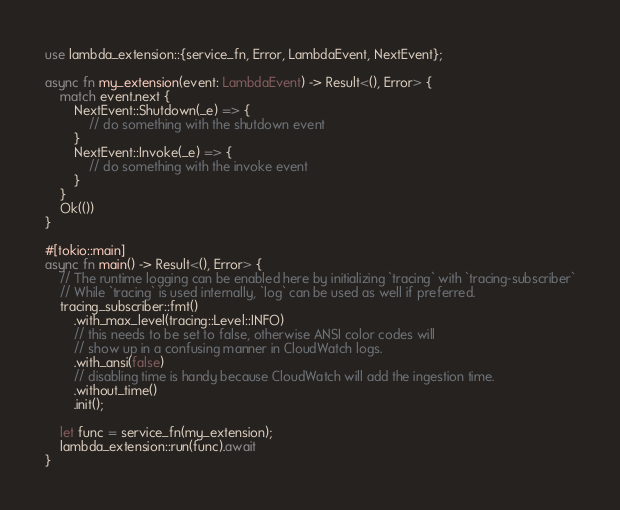<code> <loc_0><loc_0><loc_500><loc_500><_Rust_>use lambda_extension::{service_fn, Error, LambdaEvent, NextEvent};

async fn my_extension(event: LambdaEvent) -> Result<(), Error> {
    match event.next {
        NextEvent::Shutdown(_e) => {
            // do something with the shutdown event
        }
        NextEvent::Invoke(_e) => {
            // do something with the invoke event
        }
    }
    Ok(())
}

#[tokio::main]
async fn main() -> Result<(), Error> {
    // The runtime logging can be enabled here by initializing `tracing` with `tracing-subscriber`
    // While `tracing` is used internally, `log` can be used as well if preferred.
    tracing_subscriber::fmt()
        .with_max_level(tracing::Level::INFO)
        // this needs to be set to false, otherwise ANSI color codes will
        // show up in a confusing manner in CloudWatch logs.
        .with_ansi(false)
        // disabling time is handy because CloudWatch will add the ingestion time.
        .without_time()
        .init();

    let func = service_fn(my_extension);
    lambda_extension::run(func).await
}
</code> 